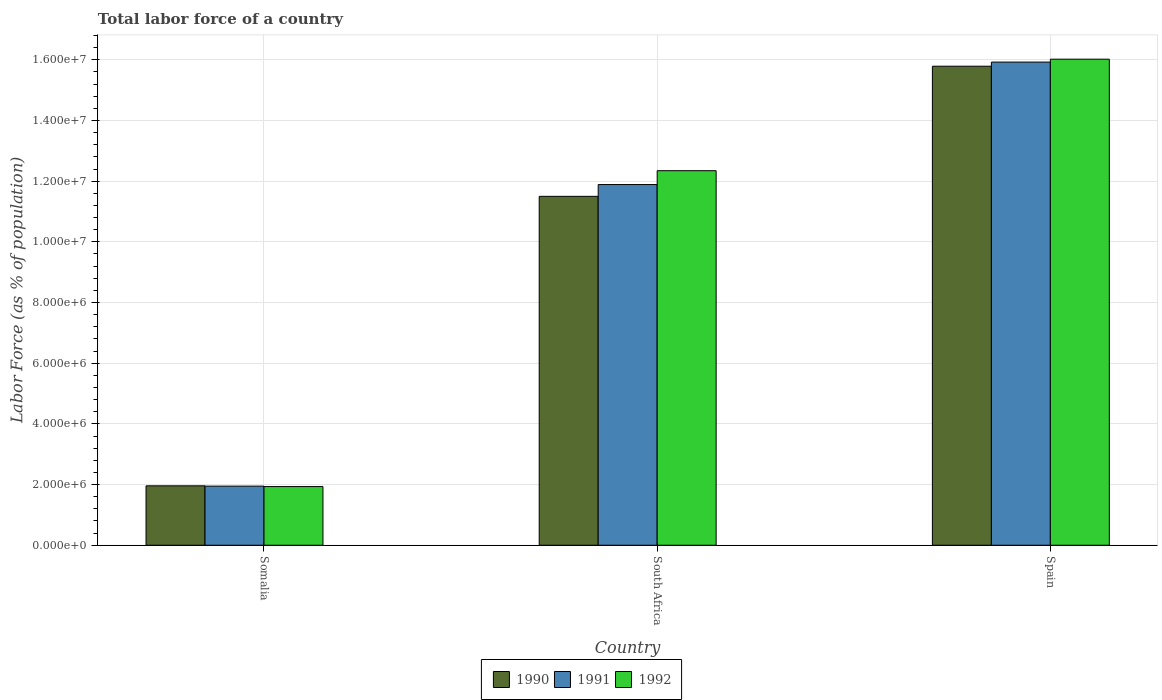How many different coloured bars are there?
Give a very brief answer. 3. Are the number of bars on each tick of the X-axis equal?
Make the answer very short. Yes. How many bars are there on the 2nd tick from the left?
Make the answer very short. 3. What is the label of the 3rd group of bars from the left?
Your answer should be compact. Spain. What is the percentage of labor force in 1990 in South Africa?
Make the answer very short. 1.15e+07. Across all countries, what is the maximum percentage of labor force in 1990?
Your answer should be very brief. 1.58e+07. Across all countries, what is the minimum percentage of labor force in 1990?
Your response must be concise. 1.96e+06. In which country was the percentage of labor force in 1991 minimum?
Offer a terse response. Somalia. What is the total percentage of labor force in 1991 in the graph?
Ensure brevity in your answer.  2.98e+07. What is the difference between the percentage of labor force in 1990 in South Africa and that in Spain?
Offer a terse response. -4.29e+06. What is the difference between the percentage of labor force in 1990 in South Africa and the percentage of labor force in 1992 in Spain?
Your answer should be compact. -4.52e+06. What is the average percentage of labor force in 1992 per country?
Ensure brevity in your answer.  1.01e+07. What is the difference between the percentage of labor force of/in 1991 and percentage of labor force of/in 1992 in Spain?
Ensure brevity in your answer.  -9.58e+04. What is the ratio of the percentage of labor force in 1990 in South Africa to that in Spain?
Give a very brief answer. 0.73. Is the percentage of labor force in 1992 in Somalia less than that in South Africa?
Provide a succinct answer. Yes. Is the difference between the percentage of labor force in 1991 in South Africa and Spain greater than the difference between the percentage of labor force in 1992 in South Africa and Spain?
Ensure brevity in your answer.  No. What is the difference between the highest and the second highest percentage of labor force in 1990?
Offer a very short reply. -1.38e+07. What is the difference between the highest and the lowest percentage of labor force in 1991?
Ensure brevity in your answer.  1.40e+07. In how many countries, is the percentage of labor force in 1990 greater than the average percentage of labor force in 1990 taken over all countries?
Provide a succinct answer. 2. What does the 2nd bar from the left in Somalia represents?
Provide a succinct answer. 1991. What does the 1st bar from the right in South Africa represents?
Your answer should be compact. 1992. How many countries are there in the graph?
Your answer should be very brief. 3. Are the values on the major ticks of Y-axis written in scientific E-notation?
Your response must be concise. Yes. Where does the legend appear in the graph?
Keep it short and to the point. Bottom center. How many legend labels are there?
Provide a succinct answer. 3. What is the title of the graph?
Provide a succinct answer. Total labor force of a country. What is the label or title of the X-axis?
Make the answer very short. Country. What is the label or title of the Y-axis?
Offer a terse response. Labor Force (as % of population). What is the Labor Force (as % of population) in 1990 in Somalia?
Offer a very short reply. 1.96e+06. What is the Labor Force (as % of population) of 1991 in Somalia?
Provide a short and direct response. 1.95e+06. What is the Labor Force (as % of population) of 1992 in Somalia?
Your response must be concise. 1.93e+06. What is the Labor Force (as % of population) of 1990 in South Africa?
Keep it short and to the point. 1.15e+07. What is the Labor Force (as % of population) in 1991 in South Africa?
Provide a succinct answer. 1.19e+07. What is the Labor Force (as % of population) in 1992 in South Africa?
Give a very brief answer. 1.23e+07. What is the Labor Force (as % of population) of 1990 in Spain?
Offer a very short reply. 1.58e+07. What is the Labor Force (as % of population) in 1991 in Spain?
Provide a short and direct response. 1.59e+07. What is the Labor Force (as % of population) of 1992 in Spain?
Provide a short and direct response. 1.60e+07. Across all countries, what is the maximum Labor Force (as % of population) of 1990?
Offer a very short reply. 1.58e+07. Across all countries, what is the maximum Labor Force (as % of population) in 1991?
Offer a terse response. 1.59e+07. Across all countries, what is the maximum Labor Force (as % of population) of 1992?
Keep it short and to the point. 1.60e+07. Across all countries, what is the minimum Labor Force (as % of population) of 1990?
Offer a terse response. 1.96e+06. Across all countries, what is the minimum Labor Force (as % of population) of 1991?
Your answer should be compact. 1.95e+06. Across all countries, what is the minimum Labor Force (as % of population) in 1992?
Your answer should be very brief. 1.93e+06. What is the total Labor Force (as % of population) in 1990 in the graph?
Make the answer very short. 2.92e+07. What is the total Labor Force (as % of population) of 1991 in the graph?
Ensure brevity in your answer.  2.98e+07. What is the total Labor Force (as % of population) in 1992 in the graph?
Give a very brief answer. 3.03e+07. What is the difference between the Labor Force (as % of population) in 1990 in Somalia and that in South Africa?
Provide a succinct answer. -9.54e+06. What is the difference between the Labor Force (as % of population) of 1991 in Somalia and that in South Africa?
Your answer should be very brief. -9.94e+06. What is the difference between the Labor Force (as % of population) of 1992 in Somalia and that in South Africa?
Give a very brief answer. -1.04e+07. What is the difference between the Labor Force (as % of population) of 1990 in Somalia and that in Spain?
Your answer should be very brief. -1.38e+07. What is the difference between the Labor Force (as % of population) of 1991 in Somalia and that in Spain?
Provide a succinct answer. -1.40e+07. What is the difference between the Labor Force (as % of population) of 1992 in Somalia and that in Spain?
Your answer should be compact. -1.41e+07. What is the difference between the Labor Force (as % of population) in 1990 in South Africa and that in Spain?
Provide a succinct answer. -4.29e+06. What is the difference between the Labor Force (as % of population) in 1991 in South Africa and that in Spain?
Ensure brevity in your answer.  -4.04e+06. What is the difference between the Labor Force (as % of population) in 1992 in South Africa and that in Spain?
Provide a short and direct response. -3.68e+06. What is the difference between the Labor Force (as % of population) in 1990 in Somalia and the Labor Force (as % of population) in 1991 in South Africa?
Your answer should be compact. -9.93e+06. What is the difference between the Labor Force (as % of population) of 1990 in Somalia and the Labor Force (as % of population) of 1992 in South Africa?
Your answer should be compact. -1.04e+07. What is the difference between the Labor Force (as % of population) in 1991 in Somalia and the Labor Force (as % of population) in 1992 in South Africa?
Your response must be concise. -1.04e+07. What is the difference between the Labor Force (as % of population) in 1990 in Somalia and the Labor Force (as % of population) in 1991 in Spain?
Make the answer very short. -1.40e+07. What is the difference between the Labor Force (as % of population) in 1990 in Somalia and the Labor Force (as % of population) in 1992 in Spain?
Offer a terse response. -1.41e+07. What is the difference between the Labor Force (as % of population) of 1991 in Somalia and the Labor Force (as % of population) of 1992 in Spain?
Make the answer very short. -1.41e+07. What is the difference between the Labor Force (as % of population) of 1990 in South Africa and the Labor Force (as % of population) of 1991 in Spain?
Your response must be concise. -4.42e+06. What is the difference between the Labor Force (as % of population) in 1990 in South Africa and the Labor Force (as % of population) in 1992 in Spain?
Ensure brevity in your answer.  -4.52e+06. What is the difference between the Labor Force (as % of population) of 1991 in South Africa and the Labor Force (as % of population) of 1992 in Spain?
Ensure brevity in your answer.  -4.13e+06. What is the average Labor Force (as % of population) in 1990 per country?
Make the answer very short. 9.75e+06. What is the average Labor Force (as % of population) in 1991 per country?
Ensure brevity in your answer.  9.92e+06. What is the average Labor Force (as % of population) in 1992 per country?
Your response must be concise. 1.01e+07. What is the difference between the Labor Force (as % of population) of 1990 and Labor Force (as % of population) of 1991 in Somalia?
Keep it short and to the point. 1.02e+04. What is the difference between the Labor Force (as % of population) of 1990 and Labor Force (as % of population) of 1992 in Somalia?
Your answer should be very brief. 2.46e+04. What is the difference between the Labor Force (as % of population) of 1991 and Labor Force (as % of population) of 1992 in Somalia?
Your answer should be compact. 1.44e+04. What is the difference between the Labor Force (as % of population) of 1990 and Labor Force (as % of population) of 1991 in South Africa?
Offer a very short reply. -3.88e+05. What is the difference between the Labor Force (as % of population) of 1990 and Labor Force (as % of population) of 1992 in South Africa?
Provide a short and direct response. -8.45e+05. What is the difference between the Labor Force (as % of population) in 1991 and Labor Force (as % of population) in 1992 in South Africa?
Offer a terse response. -4.57e+05. What is the difference between the Labor Force (as % of population) of 1990 and Labor Force (as % of population) of 1991 in Spain?
Provide a short and direct response. -1.36e+05. What is the difference between the Labor Force (as % of population) in 1990 and Labor Force (as % of population) in 1992 in Spain?
Ensure brevity in your answer.  -2.32e+05. What is the difference between the Labor Force (as % of population) of 1991 and Labor Force (as % of population) of 1992 in Spain?
Provide a succinct answer. -9.58e+04. What is the ratio of the Labor Force (as % of population) in 1990 in Somalia to that in South Africa?
Ensure brevity in your answer.  0.17. What is the ratio of the Labor Force (as % of population) in 1991 in Somalia to that in South Africa?
Keep it short and to the point. 0.16. What is the ratio of the Labor Force (as % of population) in 1992 in Somalia to that in South Africa?
Make the answer very short. 0.16. What is the ratio of the Labor Force (as % of population) of 1990 in Somalia to that in Spain?
Offer a very short reply. 0.12. What is the ratio of the Labor Force (as % of population) of 1991 in Somalia to that in Spain?
Offer a terse response. 0.12. What is the ratio of the Labor Force (as % of population) in 1992 in Somalia to that in Spain?
Ensure brevity in your answer.  0.12. What is the ratio of the Labor Force (as % of population) of 1990 in South Africa to that in Spain?
Offer a very short reply. 0.73. What is the ratio of the Labor Force (as % of population) in 1991 in South Africa to that in Spain?
Offer a terse response. 0.75. What is the ratio of the Labor Force (as % of population) of 1992 in South Africa to that in Spain?
Keep it short and to the point. 0.77. What is the difference between the highest and the second highest Labor Force (as % of population) in 1990?
Give a very brief answer. 4.29e+06. What is the difference between the highest and the second highest Labor Force (as % of population) of 1991?
Provide a short and direct response. 4.04e+06. What is the difference between the highest and the second highest Labor Force (as % of population) in 1992?
Provide a short and direct response. 3.68e+06. What is the difference between the highest and the lowest Labor Force (as % of population) of 1990?
Your response must be concise. 1.38e+07. What is the difference between the highest and the lowest Labor Force (as % of population) of 1991?
Keep it short and to the point. 1.40e+07. What is the difference between the highest and the lowest Labor Force (as % of population) of 1992?
Provide a succinct answer. 1.41e+07. 